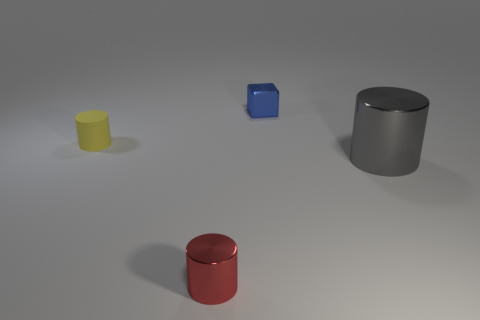How many metallic things are big green balls or tiny yellow objects?
Make the answer very short. 0. There is a tiny metallic thing on the right side of the metallic cylinder that is in front of the cylinder that is to the right of the small metallic cube; what color is it?
Your answer should be compact. Blue. The other tiny thing that is the same shape as the small rubber thing is what color?
Provide a succinct answer. Red. Are there any other things that have the same color as the small cube?
Your answer should be compact. No. What number of other objects are the same material as the blue block?
Your answer should be very brief. 2. What size is the metal block?
Provide a short and direct response. Small. Is there a big object that has the same shape as the tiny yellow rubber thing?
Provide a short and direct response. Yes. What number of things are brown blocks or cylinders right of the small yellow object?
Your answer should be compact. 2. The small object in front of the tiny rubber cylinder is what color?
Make the answer very short. Red. There is a object left of the red metallic cylinder; does it have the same size as the metal object behind the tiny yellow cylinder?
Provide a short and direct response. Yes. 